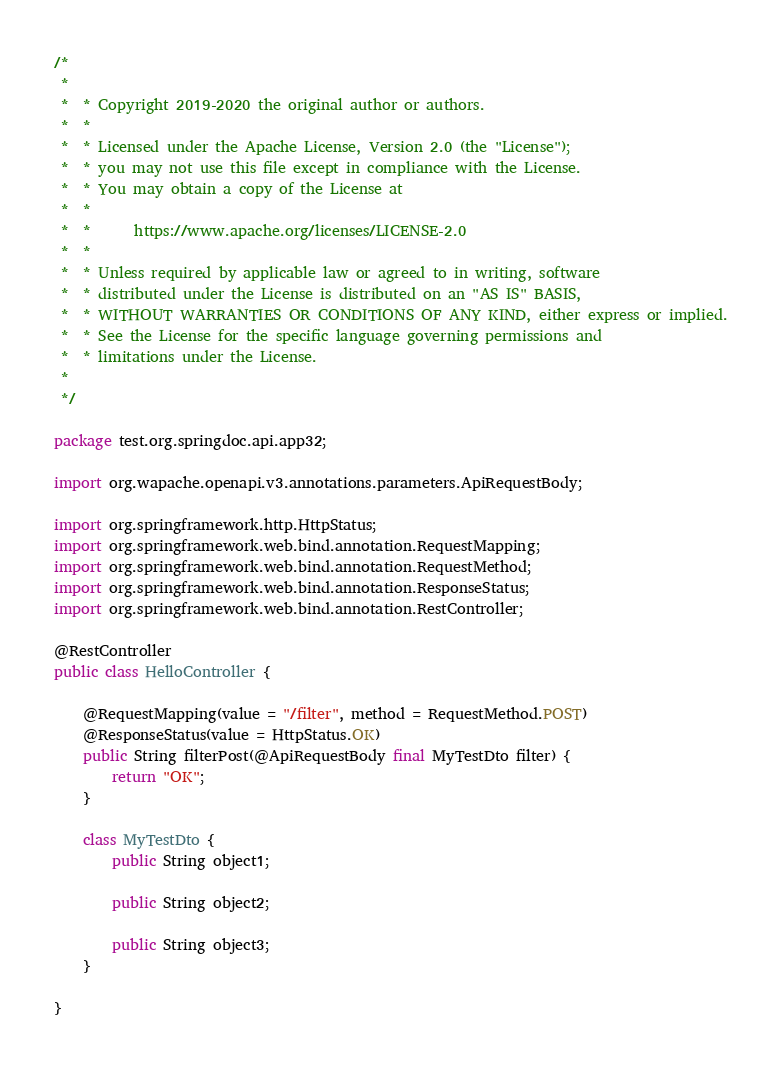<code> <loc_0><loc_0><loc_500><loc_500><_Java_>/*
 *
 *  * Copyright 2019-2020 the original author or authors.
 *  *
 *  * Licensed under the Apache License, Version 2.0 (the "License");
 *  * you may not use this file except in compliance with the License.
 *  * You may obtain a copy of the License at
 *  *
 *  *      https://www.apache.org/licenses/LICENSE-2.0
 *  *
 *  * Unless required by applicable law or agreed to in writing, software
 *  * distributed under the License is distributed on an "AS IS" BASIS,
 *  * WITHOUT WARRANTIES OR CONDITIONS OF ANY KIND, either express or implied.
 *  * See the License for the specific language governing permissions and
 *  * limitations under the License.
 *
 */

package test.org.springdoc.api.app32;

import org.wapache.openapi.v3.annotations.parameters.ApiRequestBody;

import org.springframework.http.HttpStatus;
import org.springframework.web.bind.annotation.RequestMapping;
import org.springframework.web.bind.annotation.RequestMethod;
import org.springframework.web.bind.annotation.ResponseStatus;
import org.springframework.web.bind.annotation.RestController;

@RestController
public class HelloController {

	@RequestMapping(value = "/filter", method = RequestMethod.POST)
	@ResponseStatus(value = HttpStatus.OK)
	public String filterPost(@ApiRequestBody final MyTestDto filter) {
		return "OK";
	}

	class MyTestDto {
		public String object1;

		public String object2;

		public String object3;
	}

}
</code> 